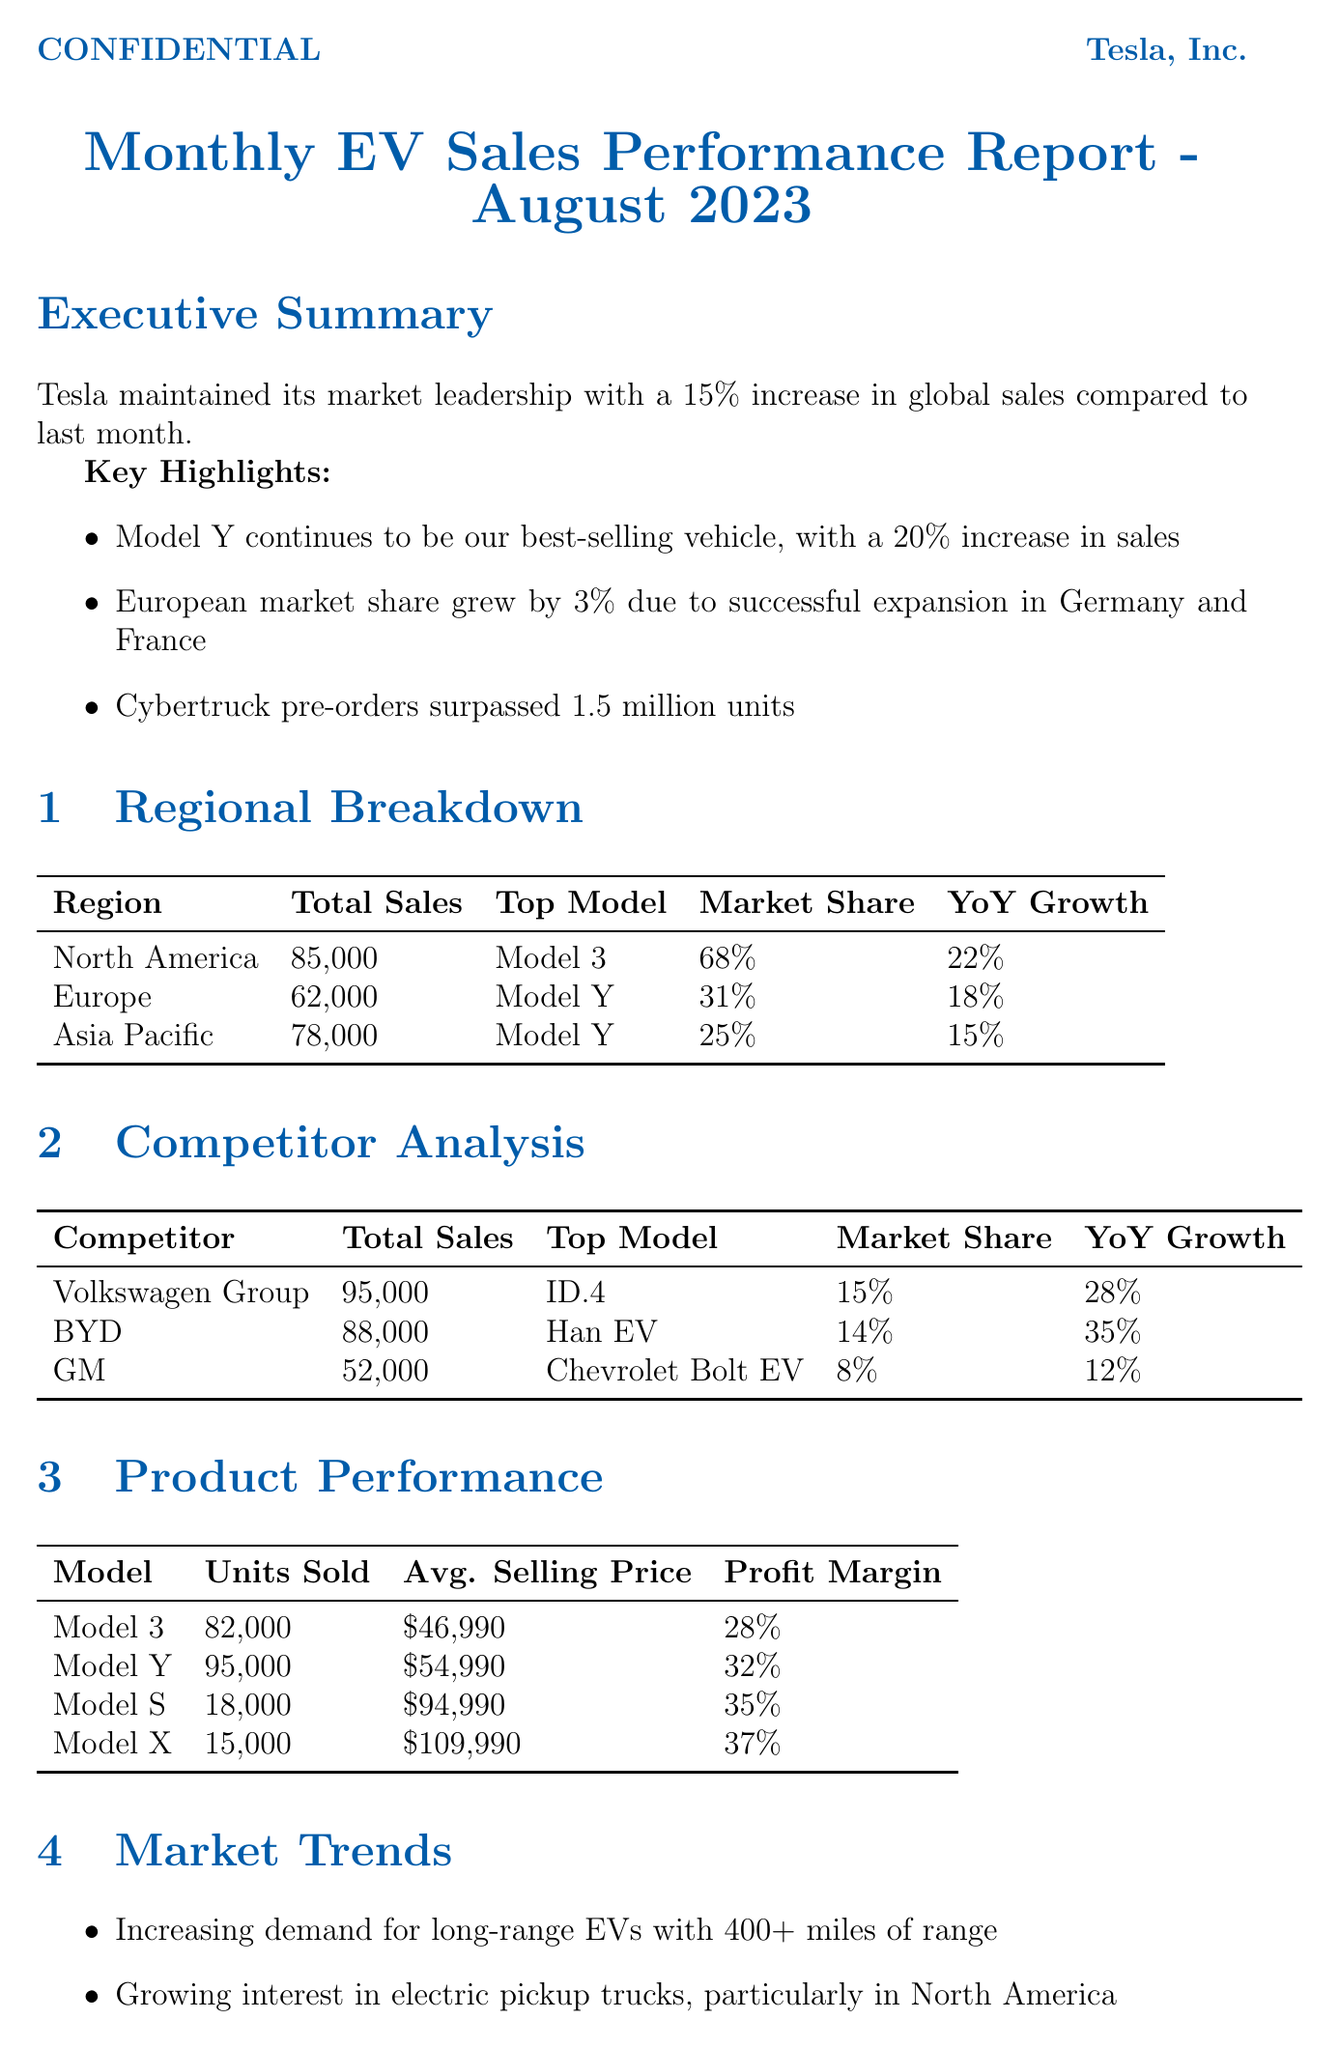what was Tesla's global sales increase percentage in August 2023? The overall performance section states Tesla maintained its market leadership with a 15% increase in global sales compared to last month.
Answer: 15% which model had the highest sales in North America? The regional breakdown for North America indicates that the top-selling model is the Model 3.
Answer: Model 3 what is the total sales for BYD? The competitor analysis section shows that BYD had total sales of 88,000 units.
Answer: 88,000 how much did the European market share grow this month? The key highlights section mentions that European market share grew by 3%.
Answer: 3% what is the average selling price of Model Y? The product performance section lists the average selling price of the Model Y as $54,990.
Answer: $54,990 what challenges does the report mention for the EV industry? The challenges subsection outlines issues including supply chain disruptions, increasing competition, and regulatory changes.
Answer: Supply chain disruptions which region had the highest year-over-year growth? In the regional breakdown, North America shows a year-over-year growth of 22%, which is the highest among the regions listed.
Answer: 22% what were Tesla's short-term goals mentioned in the report? The future outlook section lists short-term goals including increasing production capacity, launching Cybertruck production, and expanding the Supercharger network.
Answer: Increase production capacity what is the top-selling model for the Volkswagen Group? The competitor analysis section identifies the ID.4 as the top-selling model for the Volkswagen Group.
Answer: ID.4 